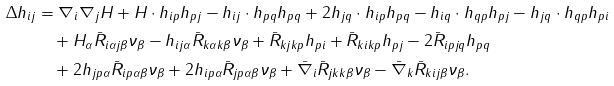<formula> <loc_0><loc_0><loc_500><loc_500>\Delta h _ { i j } & = \nabla _ { i } \nabla _ { j } H + H \cdot h _ { i p } h _ { p j } - h _ { i j } \cdot h _ { p q } h _ { p q } + 2 h _ { j q } \cdot h _ { i p } h _ { p q } - h _ { i q } \cdot h _ { q p } h _ { p j } - h _ { j q } \cdot h _ { q p } h _ { p i } \\ & \quad \null + H _ { \alpha } \bar { R } _ { i \alpha j \beta } \nu _ { \beta } - h _ { i j \alpha } \bar { R } _ { k \alpha k \beta } \nu _ { \beta } + \bar { R } _ { k j k p } h _ { p i } + \bar { R } _ { k i k p } h _ { p j } - 2 \bar { R } _ { i p j q } h _ { p q } \\ & \quad \null + 2 h _ { j p \alpha } \bar { R } _ { i p \alpha \beta } \nu _ { \beta } + 2 h _ { i p \alpha } \bar { R } _ { j p \alpha \beta } \nu _ { \beta } + \bar { \nabla } _ { i } \bar { R } _ { j k k \beta } \nu _ { \beta } - \bar { \nabla } _ { k } \bar { R } _ { k i j \beta } \nu _ { \beta } .</formula> 